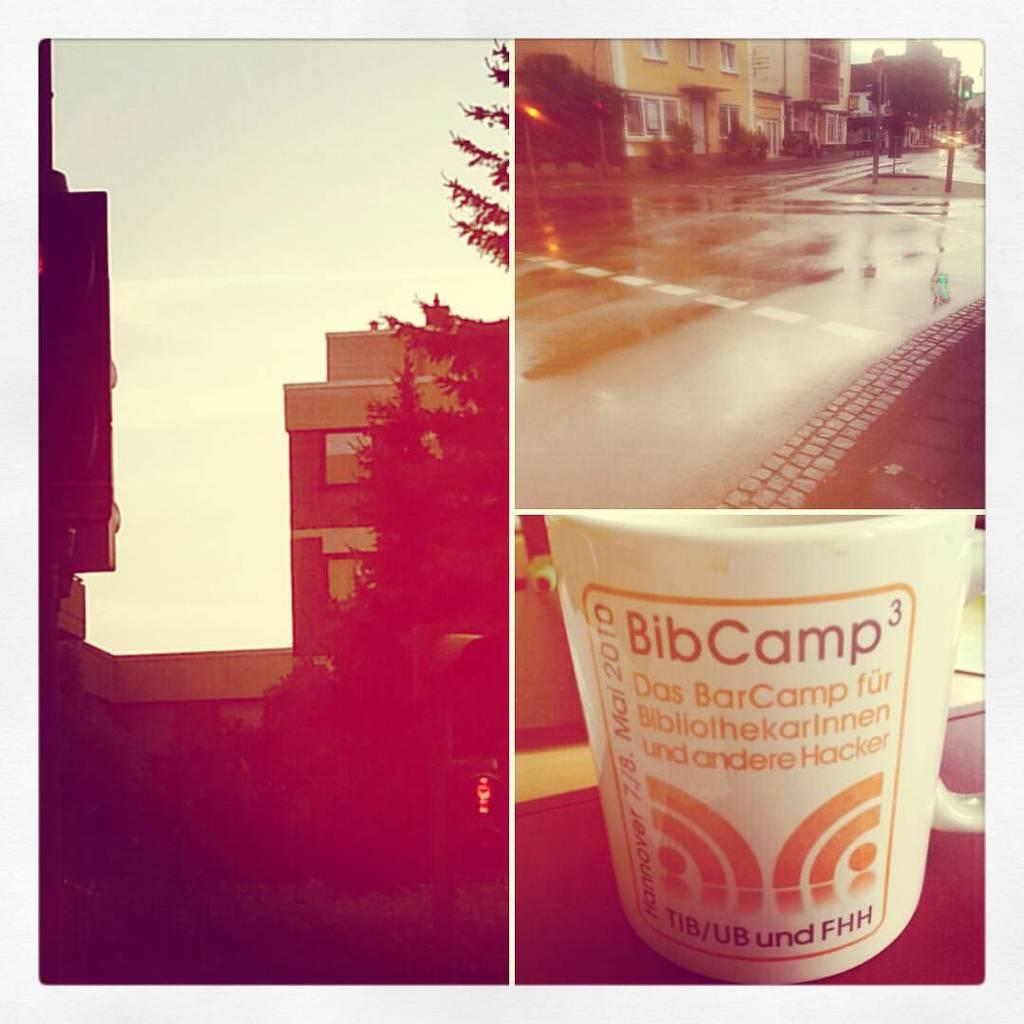<image>
Create a compact narrative representing the image presented. Three separate pictures with one of them having a cup for BibCamp 